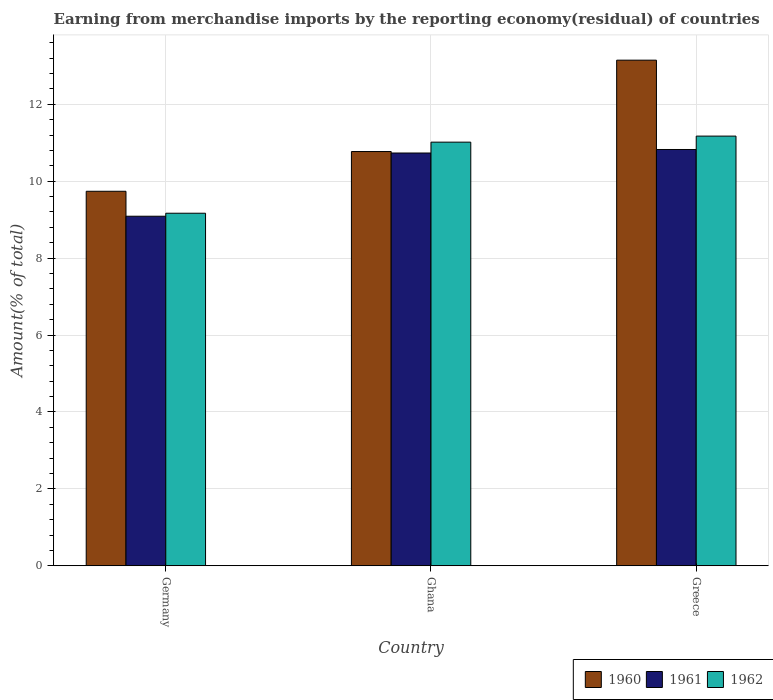Are the number of bars per tick equal to the number of legend labels?
Your answer should be very brief. Yes. Are the number of bars on each tick of the X-axis equal?
Ensure brevity in your answer.  Yes. How many bars are there on the 3rd tick from the right?
Offer a terse response. 3. What is the label of the 3rd group of bars from the left?
Your answer should be very brief. Greece. In how many cases, is the number of bars for a given country not equal to the number of legend labels?
Keep it short and to the point. 0. What is the percentage of amount earned from merchandise imports in 1960 in Ghana?
Give a very brief answer. 10.77. Across all countries, what is the maximum percentage of amount earned from merchandise imports in 1960?
Offer a terse response. 13.15. Across all countries, what is the minimum percentage of amount earned from merchandise imports in 1961?
Your answer should be very brief. 9.09. In which country was the percentage of amount earned from merchandise imports in 1962 minimum?
Provide a succinct answer. Germany. What is the total percentage of amount earned from merchandise imports in 1961 in the graph?
Offer a terse response. 30.64. What is the difference between the percentage of amount earned from merchandise imports in 1962 in Germany and that in Ghana?
Keep it short and to the point. -1.85. What is the difference between the percentage of amount earned from merchandise imports in 1961 in Greece and the percentage of amount earned from merchandise imports in 1962 in Ghana?
Offer a terse response. -0.19. What is the average percentage of amount earned from merchandise imports in 1960 per country?
Ensure brevity in your answer.  11.22. What is the difference between the percentage of amount earned from merchandise imports of/in 1960 and percentage of amount earned from merchandise imports of/in 1961 in Ghana?
Offer a very short reply. 0.04. What is the ratio of the percentage of amount earned from merchandise imports in 1962 in Ghana to that in Greece?
Keep it short and to the point. 0.99. What is the difference between the highest and the second highest percentage of amount earned from merchandise imports in 1961?
Your response must be concise. -1.73. What is the difference between the highest and the lowest percentage of amount earned from merchandise imports in 1962?
Provide a short and direct response. 2.01. Is the sum of the percentage of amount earned from merchandise imports in 1962 in Germany and Greece greater than the maximum percentage of amount earned from merchandise imports in 1961 across all countries?
Your answer should be very brief. Yes. What does the 2nd bar from the left in Ghana represents?
Your answer should be compact. 1961. What does the 1st bar from the right in Ghana represents?
Provide a short and direct response. 1962. How many bars are there?
Offer a terse response. 9. Are all the bars in the graph horizontal?
Your answer should be compact. No. How many countries are there in the graph?
Your response must be concise. 3. Are the values on the major ticks of Y-axis written in scientific E-notation?
Offer a terse response. No. Does the graph contain any zero values?
Give a very brief answer. No. Where does the legend appear in the graph?
Your response must be concise. Bottom right. What is the title of the graph?
Give a very brief answer. Earning from merchandise imports by the reporting economy(residual) of countries. What is the label or title of the Y-axis?
Your answer should be compact. Amount(% of total). What is the Amount(% of total) of 1960 in Germany?
Provide a short and direct response. 9.74. What is the Amount(% of total) of 1961 in Germany?
Your response must be concise. 9.09. What is the Amount(% of total) of 1962 in Germany?
Make the answer very short. 9.17. What is the Amount(% of total) in 1960 in Ghana?
Keep it short and to the point. 10.77. What is the Amount(% of total) of 1961 in Ghana?
Keep it short and to the point. 10.73. What is the Amount(% of total) in 1962 in Ghana?
Keep it short and to the point. 11.01. What is the Amount(% of total) in 1960 in Greece?
Your answer should be compact. 13.15. What is the Amount(% of total) in 1961 in Greece?
Ensure brevity in your answer.  10.82. What is the Amount(% of total) of 1962 in Greece?
Ensure brevity in your answer.  11.17. Across all countries, what is the maximum Amount(% of total) of 1960?
Provide a short and direct response. 13.15. Across all countries, what is the maximum Amount(% of total) in 1961?
Ensure brevity in your answer.  10.82. Across all countries, what is the maximum Amount(% of total) in 1962?
Give a very brief answer. 11.17. Across all countries, what is the minimum Amount(% of total) of 1960?
Make the answer very short. 9.74. Across all countries, what is the minimum Amount(% of total) in 1961?
Provide a succinct answer. 9.09. Across all countries, what is the minimum Amount(% of total) of 1962?
Keep it short and to the point. 9.17. What is the total Amount(% of total) of 1960 in the graph?
Ensure brevity in your answer.  33.65. What is the total Amount(% of total) in 1961 in the graph?
Your answer should be very brief. 30.64. What is the total Amount(% of total) of 1962 in the graph?
Your answer should be very brief. 31.35. What is the difference between the Amount(% of total) in 1960 in Germany and that in Ghana?
Offer a very short reply. -1.03. What is the difference between the Amount(% of total) of 1961 in Germany and that in Ghana?
Provide a short and direct response. -1.64. What is the difference between the Amount(% of total) in 1962 in Germany and that in Ghana?
Give a very brief answer. -1.85. What is the difference between the Amount(% of total) in 1960 in Germany and that in Greece?
Keep it short and to the point. -3.41. What is the difference between the Amount(% of total) of 1961 in Germany and that in Greece?
Your answer should be very brief. -1.74. What is the difference between the Amount(% of total) in 1962 in Germany and that in Greece?
Offer a very short reply. -2.01. What is the difference between the Amount(% of total) of 1960 in Ghana and that in Greece?
Offer a terse response. -2.38. What is the difference between the Amount(% of total) of 1961 in Ghana and that in Greece?
Provide a succinct answer. -0.09. What is the difference between the Amount(% of total) of 1962 in Ghana and that in Greece?
Provide a succinct answer. -0.16. What is the difference between the Amount(% of total) of 1960 in Germany and the Amount(% of total) of 1961 in Ghana?
Your answer should be compact. -0.99. What is the difference between the Amount(% of total) of 1960 in Germany and the Amount(% of total) of 1962 in Ghana?
Make the answer very short. -1.28. What is the difference between the Amount(% of total) in 1961 in Germany and the Amount(% of total) in 1962 in Ghana?
Provide a short and direct response. -1.93. What is the difference between the Amount(% of total) in 1960 in Germany and the Amount(% of total) in 1961 in Greece?
Provide a succinct answer. -1.09. What is the difference between the Amount(% of total) in 1960 in Germany and the Amount(% of total) in 1962 in Greece?
Your answer should be compact. -1.43. What is the difference between the Amount(% of total) of 1961 in Germany and the Amount(% of total) of 1962 in Greece?
Your answer should be very brief. -2.08. What is the difference between the Amount(% of total) in 1960 in Ghana and the Amount(% of total) in 1961 in Greece?
Give a very brief answer. -0.05. What is the difference between the Amount(% of total) in 1960 in Ghana and the Amount(% of total) in 1962 in Greece?
Offer a very short reply. -0.4. What is the difference between the Amount(% of total) of 1961 in Ghana and the Amount(% of total) of 1962 in Greece?
Make the answer very short. -0.44. What is the average Amount(% of total) of 1960 per country?
Your answer should be compact. 11.22. What is the average Amount(% of total) in 1961 per country?
Ensure brevity in your answer.  10.21. What is the average Amount(% of total) in 1962 per country?
Make the answer very short. 10.45. What is the difference between the Amount(% of total) of 1960 and Amount(% of total) of 1961 in Germany?
Give a very brief answer. 0.65. What is the difference between the Amount(% of total) of 1960 and Amount(% of total) of 1962 in Germany?
Your answer should be very brief. 0.57. What is the difference between the Amount(% of total) in 1961 and Amount(% of total) in 1962 in Germany?
Your answer should be very brief. -0.08. What is the difference between the Amount(% of total) of 1960 and Amount(% of total) of 1961 in Ghana?
Give a very brief answer. 0.04. What is the difference between the Amount(% of total) of 1960 and Amount(% of total) of 1962 in Ghana?
Make the answer very short. -0.24. What is the difference between the Amount(% of total) of 1961 and Amount(% of total) of 1962 in Ghana?
Keep it short and to the point. -0.28. What is the difference between the Amount(% of total) in 1960 and Amount(% of total) in 1961 in Greece?
Offer a terse response. 2.32. What is the difference between the Amount(% of total) of 1960 and Amount(% of total) of 1962 in Greece?
Give a very brief answer. 1.97. What is the difference between the Amount(% of total) in 1961 and Amount(% of total) in 1962 in Greece?
Provide a short and direct response. -0.35. What is the ratio of the Amount(% of total) in 1960 in Germany to that in Ghana?
Ensure brevity in your answer.  0.9. What is the ratio of the Amount(% of total) of 1961 in Germany to that in Ghana?
Provide a succinct answer. 0.85. What is the ratio of the Amount(% of total) in 1962 in Germany to that in Ghana?
Give a very brief answer. 0.83. What is the ratio of the Amount(% of total) of 1960 in Germany to that in Greece?
Ensure brevity in your answer.  0.74. What is the ratio of the Amount(% of total) in 1961 in Germany to that in Greece?
Provide a short and direct response. 0.84. What is the ratio of the Amount(% of total) of 1962 in Germany to that in Greece?
Offer a very short reply. 0.82. What is the ratio of the Amount(% of total) in 1960 in Ghana to that in Greece?
Offer a terse response. 0.82. What is the ratio of the Amount(% of total) in 1962 in Ghana to that in Greece?
Keep it short and to the point. 0.99. What is the difference between the highest and the second highest Amount(% of total) in 1960?
Offer a terse response. 2.38. What is the difference between the highest and the second highest Amount(% of total) of 1961?
Your answer should be compact. 0.09. What is the difference between the highest and the second highest Amount(% of total) of 1962?
Provide a short and direct response. 0.16. What is the difference between the highest and the lowest Amount(% of total) in 1960?
Provide a succinct answer. 3.41. What is the difference between the highest and the lowest Amount(% of total) in 1961?
Your answer should be compact. 1.74. What is the difference between the highest and the lowest Amount(% of total) in 1962?
Make the answer very short. 2.01. 